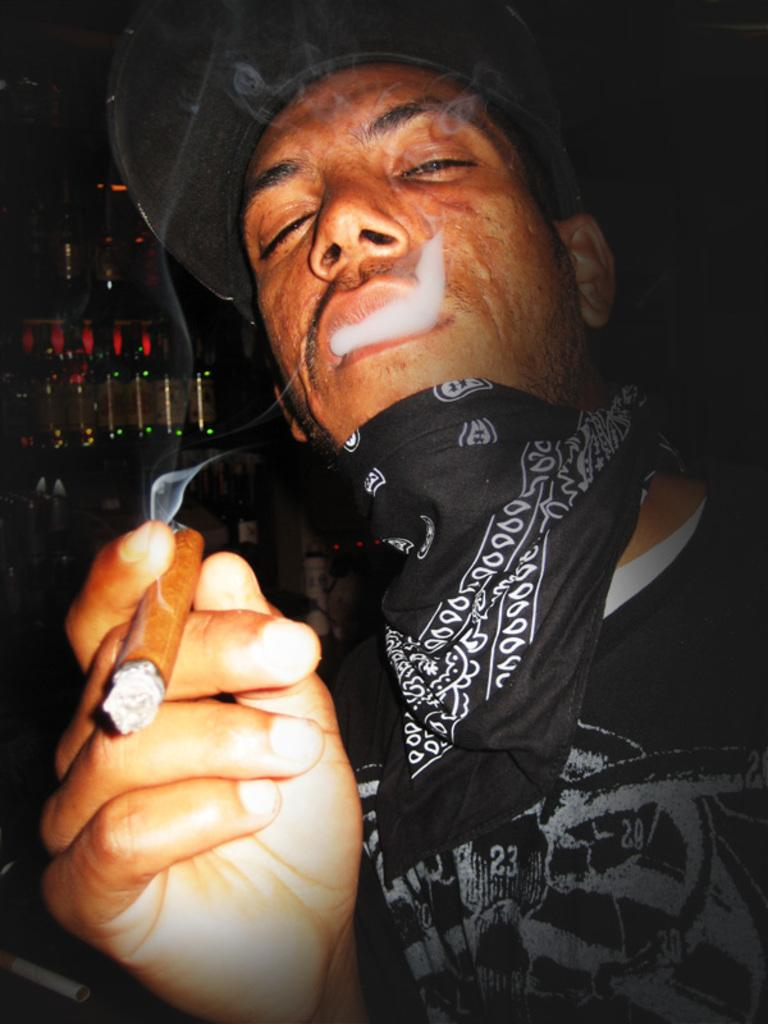Who is present in the image? There is a man in the image. What is the man doing in the image? The man is smoking. What can be seen behind the man in the image? There are alcohol bottles behind the man. What color is the shirt the man is wearing? The man is wearing a black shirt. What type of headwear is the man wearing? The man is wearing a black hat. What type of soup is being served for dinner in the image? There is no soup or dinner present in the image; it features a man smoking with alcohol bottles behind him. 